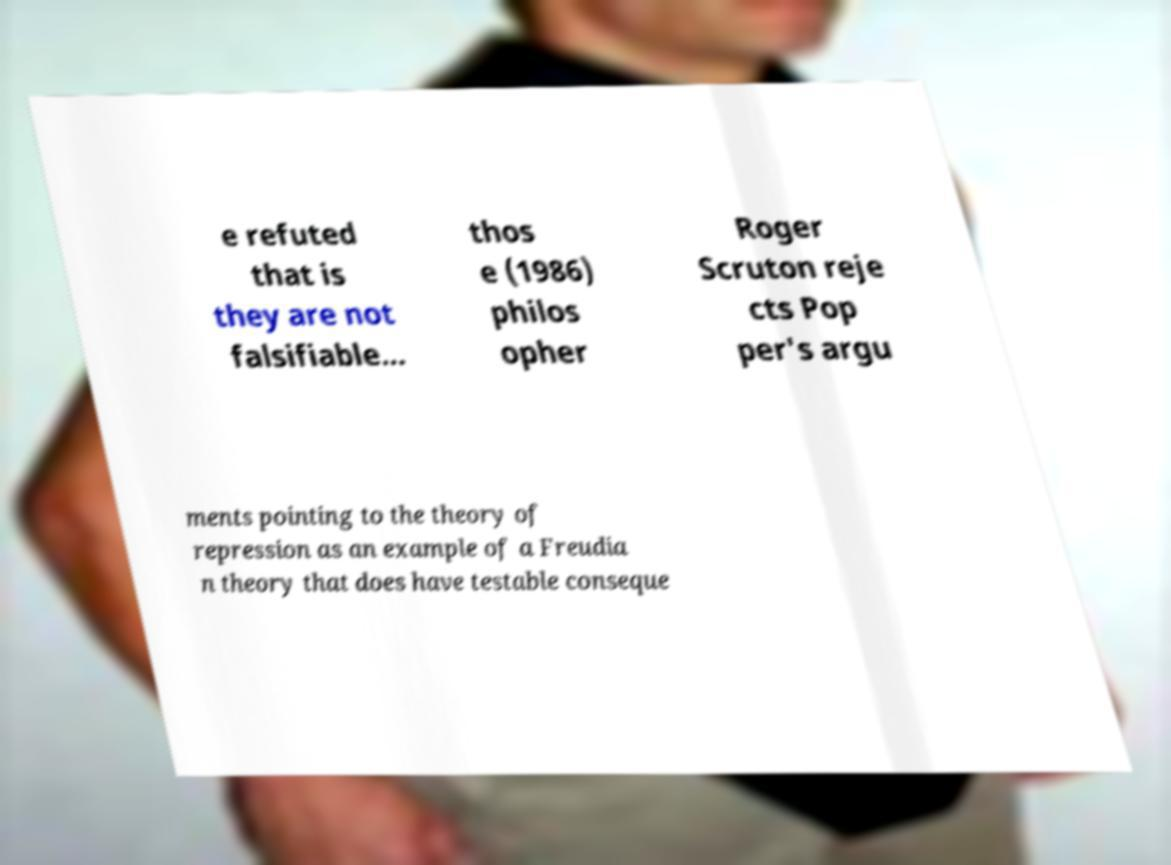Can you read and provide the text displayed in the image?This photo seems to have some interesting text. Can you extract and type it out for me? e refuted that is they are not falsifiable... thos e (1986) philos opher Roger Scruton reje cts Pop per's argu ments pointing to the theory of repression as an example of a Freudia n theory that does have testable conseque 